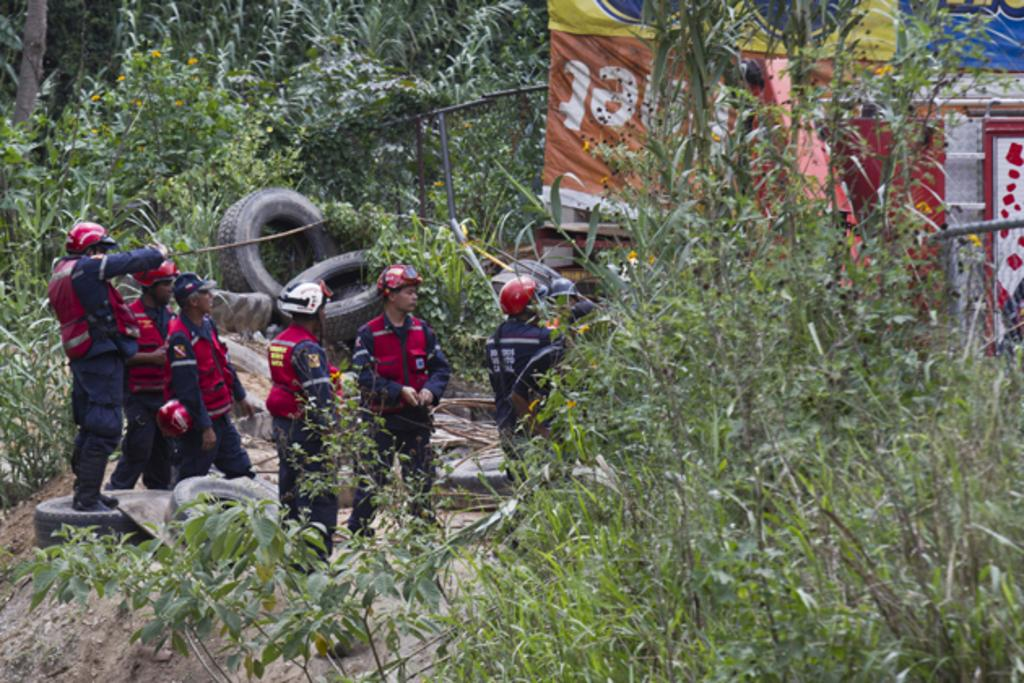How many people are in the image? There are people in the image, but the exact number is not specified. What are the people wearing? The people are wearing the same dress. What is the surface that the people are standing on? The people are standing on a floor. What objects can be seen on the floor? There are tires on the floor. What type of natural elements are present in the image? There are trees and plants in the image. What else can be seen on the walls or surfaces in the image? There are posters in the image. What type of toothpaste is the squirrel using in the image? There is no squirrel or toothpaste present in the image. 